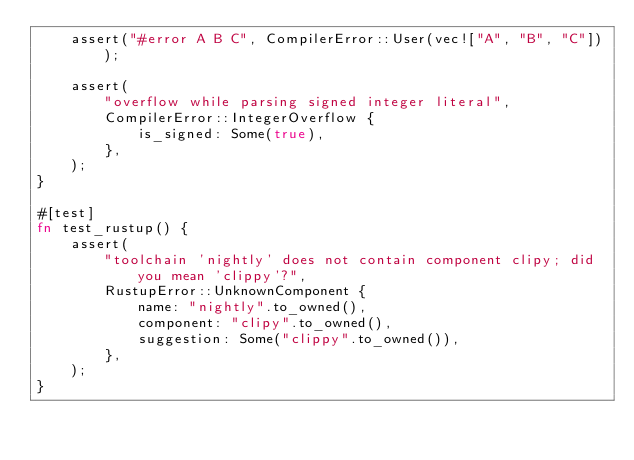Convert code to text. <code><loc_0><loc_0><loc_500><loc_500><_Rust_>    assert("#error A B C", CompilerError::User(vec!["A", "B", "C"]));

    assert(
        "overflow while parsing signed integer literal",
        CompilerError::IntegerOverflow {
            is_signed: Some(true),
        },
    );
}

#[test]
fn test_rustup() {
    assert(
        "toolchain 'nightly' does not contain component clipy; did you mean 'clippy'?",
        RustupError::UnknownComponent {
            name: "nightly".to_owned(),
            component: "clipy".to_owned(),
            suggestion: Some("clippy".to_owned()),
        },
    );
}
</code> 